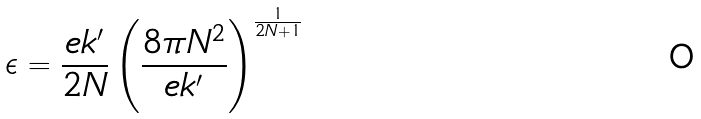<formula> <loc_0><loc_0><loc_500><loc_500>\epsilon = \frac { e k ^ { \prime } } { 2 N } \left ( \frac { 8 \pi N ^ { 2 } } { e k ^ { \prime } } \right ) ^ { \frac { 1 } { 2 N + 1 } }</formula> 